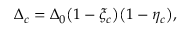<formula> <loc_0><loc_0><loc_500><loc_500>\Delta _ { c } = \Delta _ { 0 } \left ( 1 - \xi _ { c } \right ) \left ( 1 - \eta _ { c } \right ) ,</formula> 